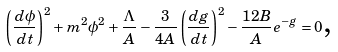<formula> <loc_0><loc_0><loc_500><loc_500>\left ( \frac { d \phi } { d t } \right ) ^ { 2 } + m ^ { 2 } \phi ^ { 2 } + \frac { \Lambda } { A } - \frac { 3 } { 4 A } \left ( \frac { d g } { d t } \right ) ^ { 2 } - \frac { 1 2 B } { A } e ^ { - g } = 0 \text {,}</formula> 